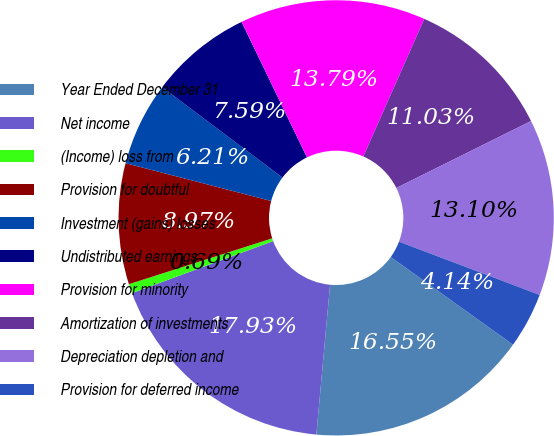Convert chart. <chart><loc_0><loc_0><loc_500><loc_500><pie_chart><fcel>Year Ended December 31<fcel>Net income<fcel>(Income) loss from<fcel>Provision for doubtful<fcel>Investment (gains) losses<fcel>Undistributed earnings<fcel>Provision for minority<fcel>Amortization of investments<fcel>Depreciation depletion and<fcel>Provision for deferred income<nl><fcel>16.55%<fcel>17.93%<fcel>0.69%<fcel>8.97%<fcel>6.21%<fcel>7.59%<fcel>13.79%<fcel>11.03%<fcel>13.1%<fcel>4.14%<nl></chart> 